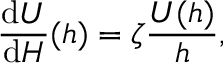<formula> <loc_0><loc_0><loc_500><loc_500>{ \frac { d U } { d H } } ( h ) = \zeta { \frac { U ( h ) } { h } } ,</formula> 